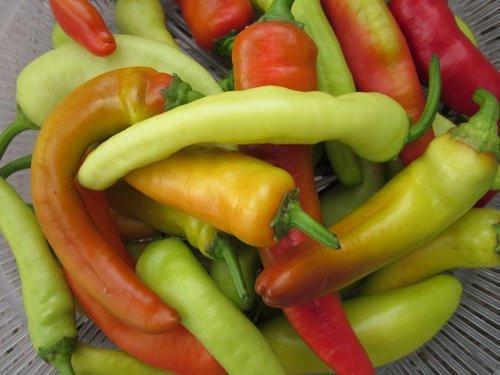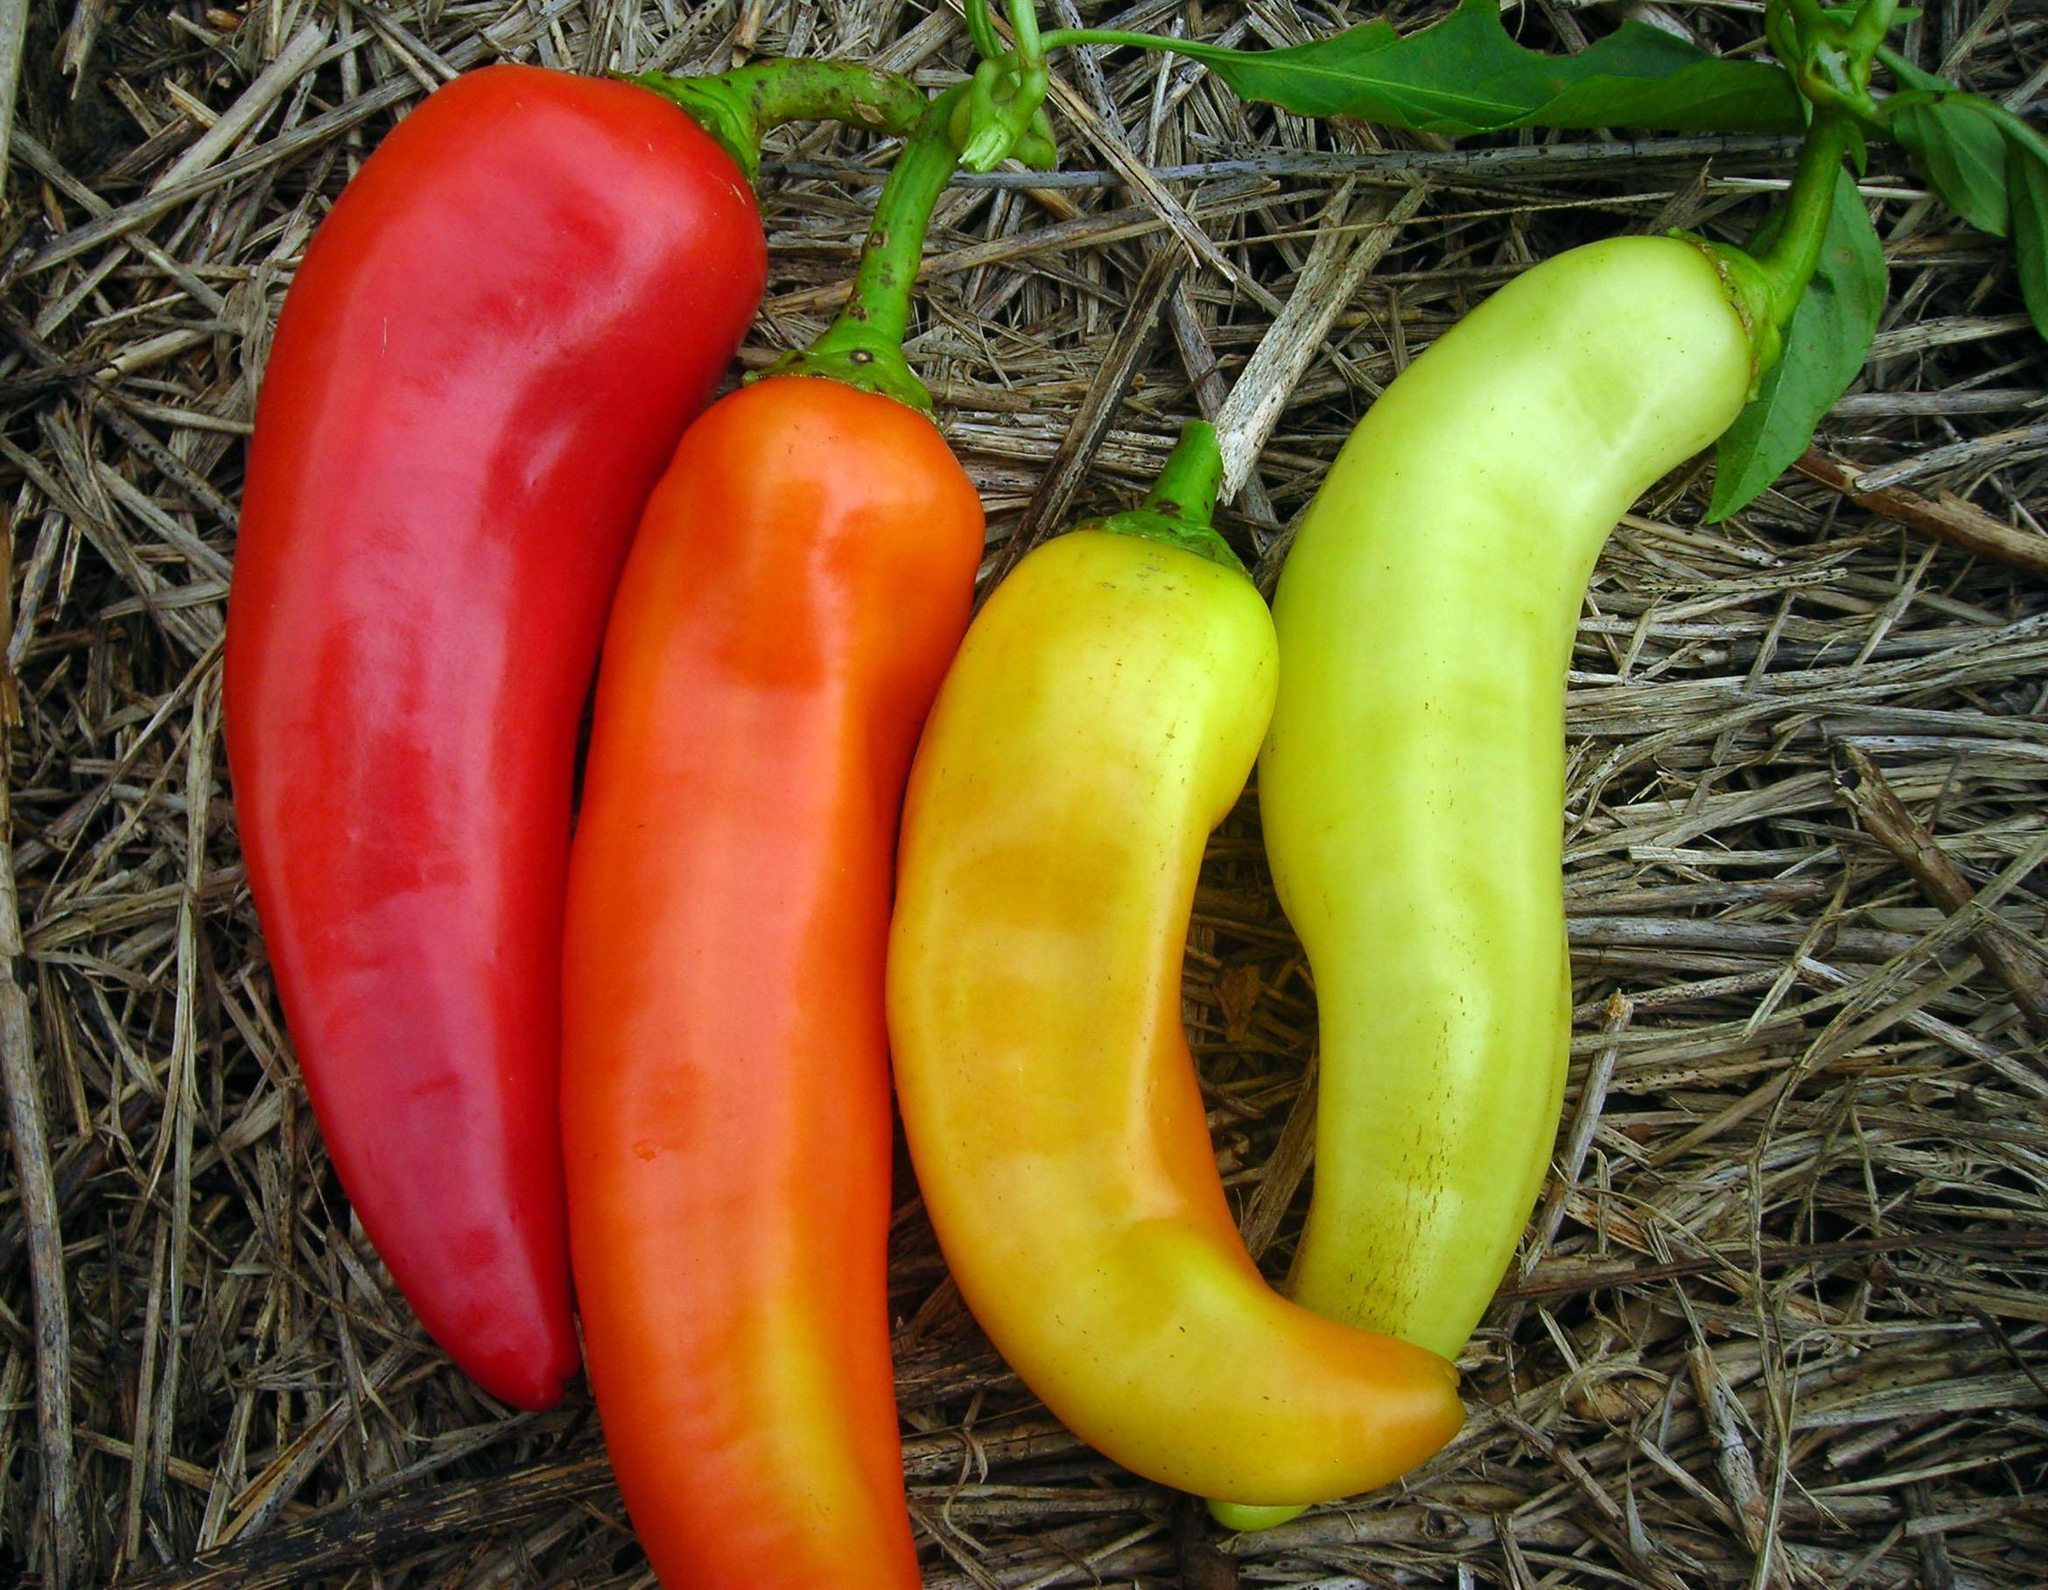The first image is the image on the left, the second image is the image on the right. Evaluate the accuracy of this statement regarding the images: "Both images in the pair show hot peppers that are yellow, orange, red, and green.". Is it true? Answer yes or no. Yes. The first image is the image on the left, the second image is the image on the right. For the images displayed, is the sentence "The right image shows a neat row of picked peppers that includes red, orange, and yellow color varieties." factually correct? Answer yes or no. Yes. 